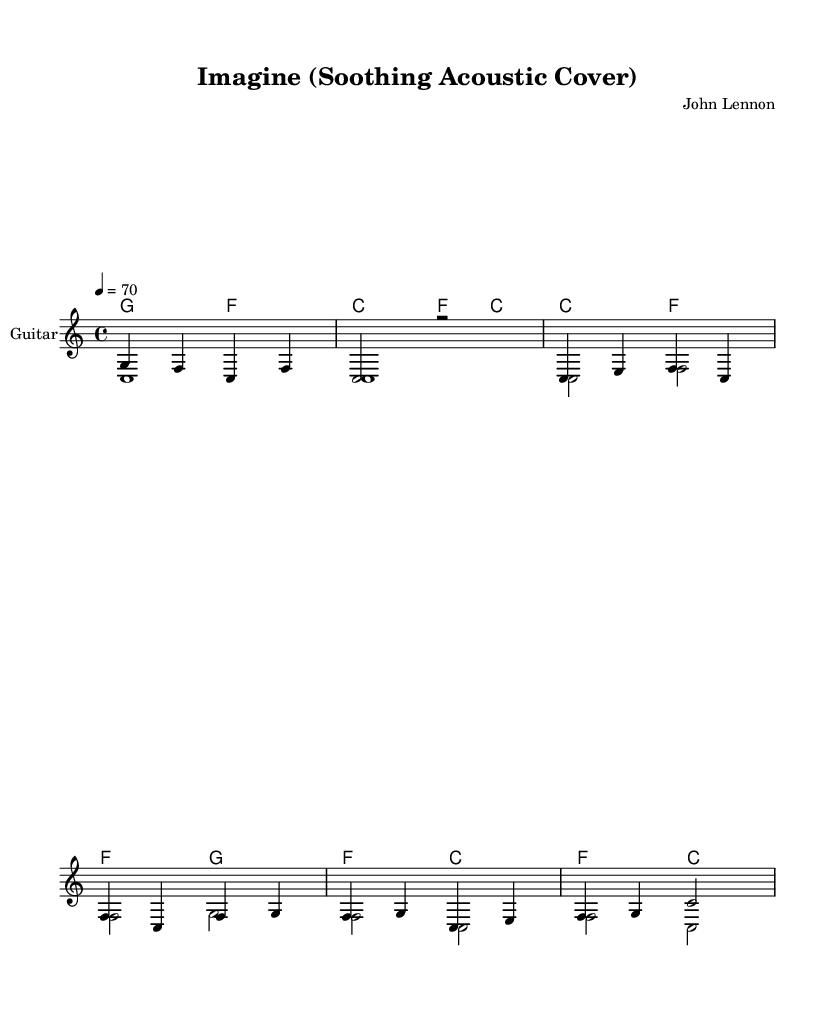What is the key signature of this music? The key signature is determined by looking at the key indicated at the beginning of the piece. Here, it shows C major, which is represented with no sharps or flats.
Answer: C major What is the time signature of this music? The time signature is displayed at the beginning, indicating how the beats are organized in the piece. In this score, it shows 4/4, meaning there are four beats per measure.
Answer: 4/4 What is the tempo of this music? The tempo is noted in the score by the number that indicates beats per minute. Here, it specifies a tempo of 70, indicating that there are 70 beats in one minute.
Answer: 70 How many measures are in the introduction section? To determine the number of measures, we count the individual segments in the introduction part of the score. The introduction consists of two measures.
Answer: 2 What is the main instrument used in this piece? The main instrument is identified through the instrument name provided in the staff. In this score, it is labeled as "Guitar."
Answer: Guitar What type of musical piece is this? The title and style described in the header indicate the nature of the piece. The music is an acoustic cover, and the title "Imagine" suggests it is a cover of a classic song.
Answer: Acoustic cover What are the two voices indicated in the score? The voices are noted under the staff labels, providing clarity on which parts are present in the arrangement. Here, the voices are labeled as "guitar" and "cello."
Answer: guitar and cello 